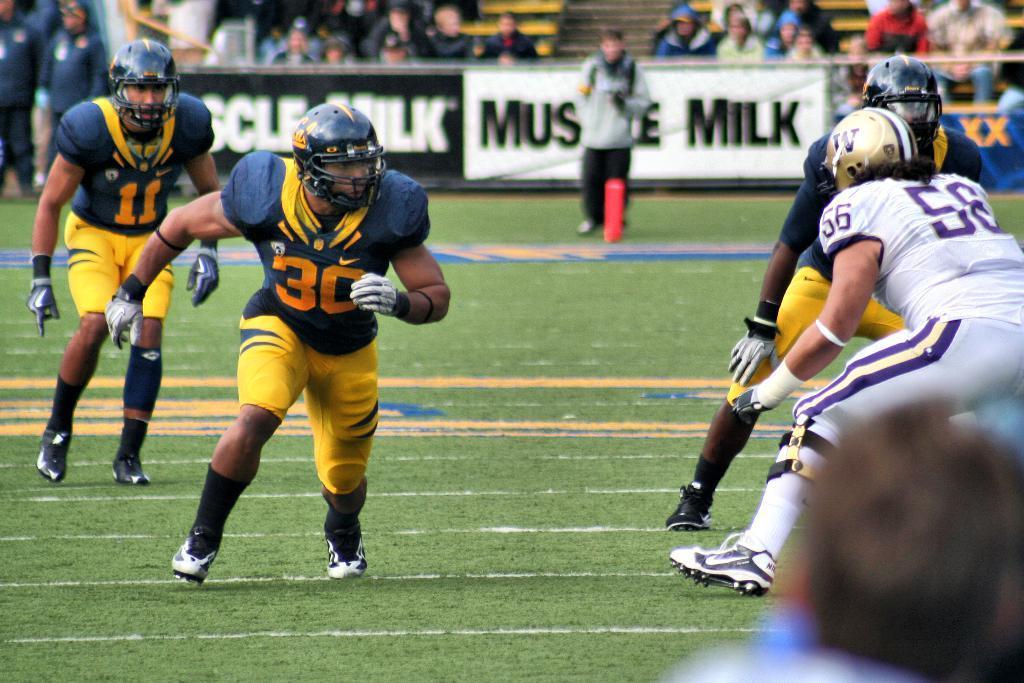How would you summarize this image in a sentence or two? In the image we can see there are people wearing clothes, gloves, helmet, socks and shoes. They are running and some of them are standing. Here we can see grass and white lines on it. We can even see the posters and on it there is a text. 